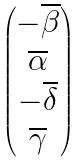<formula> <loc_0><loc_0><loc_500><loc_500>\begin{pmatrix} - \overline { \beta } \\ \overline { \alpha } \\ - \overline { \delta } \\ \overline { \gamma } \end{pmatrix}</formula> 